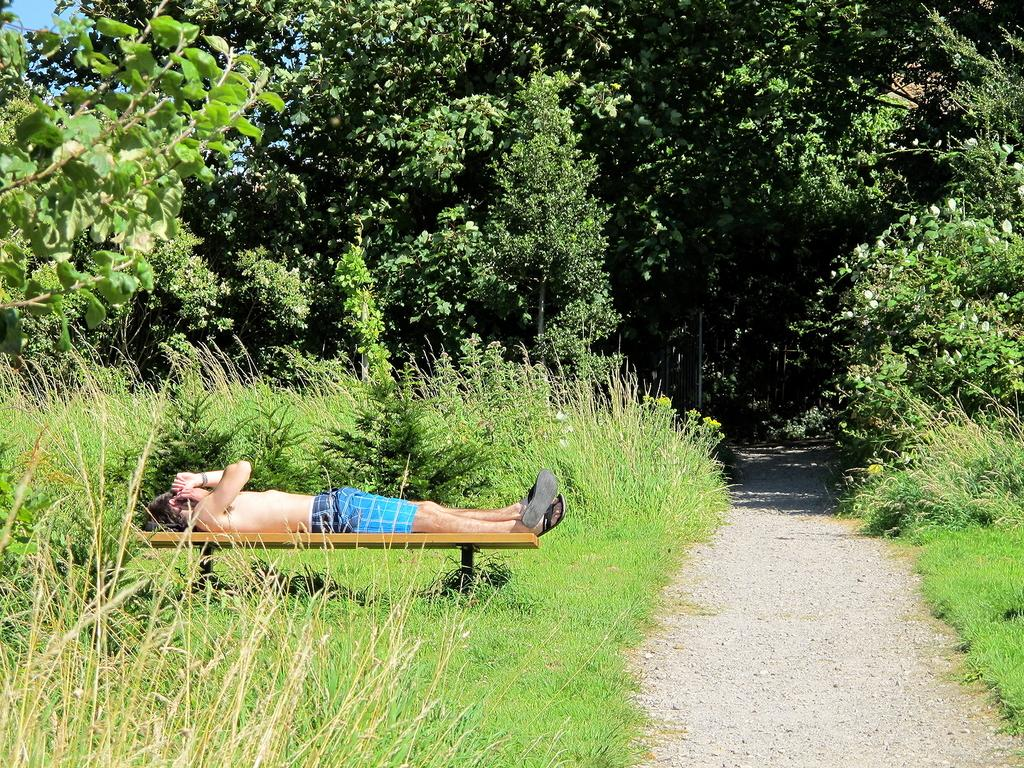What is the man in the image doing? The man is lying on a bench in the image. What type of vegetation can be seen in the image? There are plants, trees, and grass visible in the image. Where is the path located in the image? The path is on the left side of the image. What time of day is it in the image, based on the hour shown on the pancake? There is no pancake present in the image, so it is not possible to determine the time of day based on an hour shown on a pancake. 